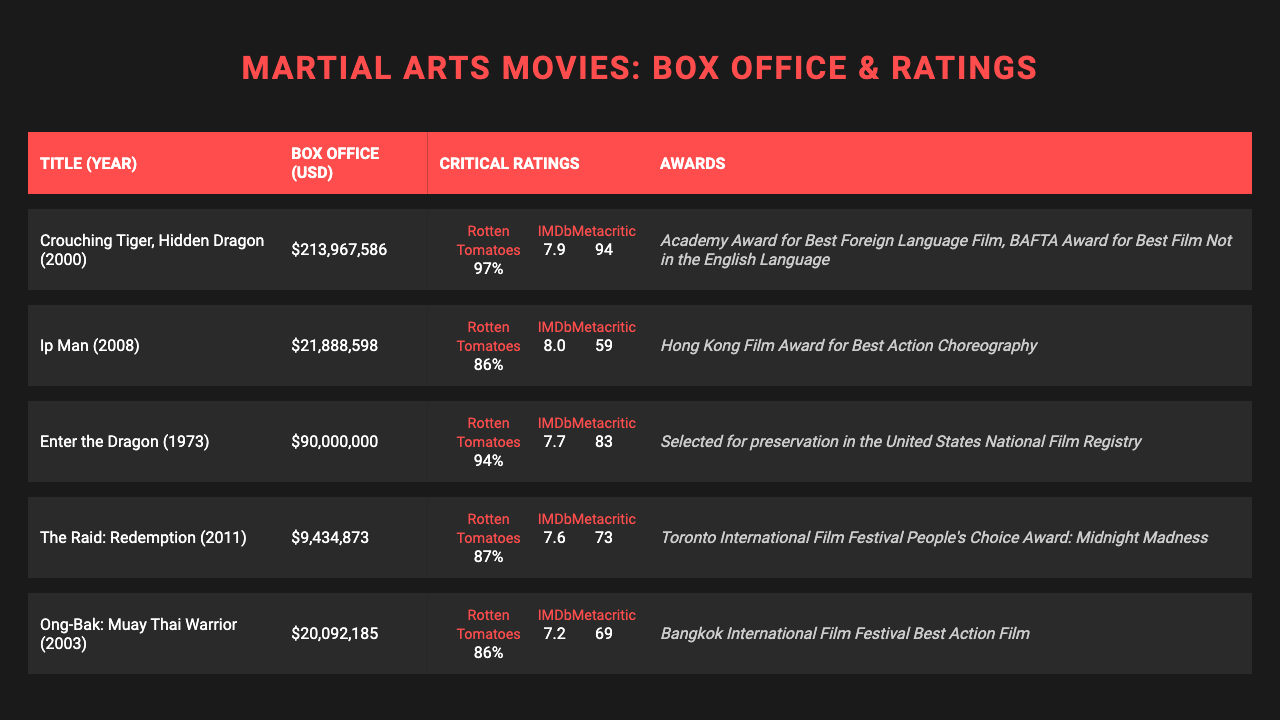What is the box office earning for "Crouching Tiger, Hidden Dragon"? The box office earning is listed directly in the table for each movie. For "Crouching Tiger, Hidden Dragon," it states the earning as $213,967,586.
Answer: $213,967,586 Which movie has the highest average critical rating? To find the highest average rating, we will calculate the average of the available ratings (Rotten Tomatoes, IMDb, and Metacritic) for each movie. The averages are: "Crouching Tiger, Hidden Dragon" (96.67), "Enter the Dragon" (90.33), "Ip Man" (78.33), "The Raid: Redemption" (79.33), and "Ong-Bak: Muay Thai Warrior" (74.33). "Crouching Tiger, Hidden Dragon" has the highest average rating.
Answer: Crouching Tiger, Hidden Dragon Did "The Raid: Redemption" win any awards? The table lists the awards for each movie under a specific column. "The Raid: Redemption" has one award listed: "Toronto International Film Festival People's Choice Award: Midnight Madness". Since it won this award, the answer is yes.
Answer: Yes What is the difference in box office earnings between "Ip Man" and "Ong-Bak: Muay Thai Warrior"? The box office earnings for "Ip Man" is $21,888,598, and for "Ong-Bak: Muay Thai Warrior," it's $20,092,185. The difference is calculated as $21,888,598 - $20,092,185 = $1,796,413.
Answer: $1,796,413 Which movie released in 2003 has the lowest IMDb rating? From the table, we can filter the movies released in 2003. The only movie is "Ong-Bak: Muay Thai Warrior," which has an IMDb rating of 7.2. Since it’s the only movie from that year, it has the lowest rating by default.
Answer: Ong-Bak: Muay Thai Warrior What percent of the box office earnings of "Enter the Dragon" (USD 90,000,000) does "Ong-Bak: Muay Thai Warrior" (USD 20,092,185) represent? The percentage can be calculated by dividing the box office of "Ong-Bak: Muay Thai Warrior" by that of "Enter the Dragon" and multiplying by 100: (20,092,185 / 90,000,000) * 100 ≈ 22.32%.
Answer: 22.32% How many awards does "Crouching Tiger, Hidden Dragon" have? We can directly count the awards listed under the column for "Crouching Tiger, Hidden Dragon." It shows two awards: "Academy Award for Best Foreign Language Film" and "BAFTA Award for Best Film Not in the English Language." Thus, there are two awards in total.
Answer: 2 Is it true that "Ip Man" has a higher Rotten Tomatoes rating than "The Raid: Redemption"? By checking the Rotten Tomatoes ratings from the table, "Ip Man" has a rating of 86%, while "The Raid: Redemption" has a rating of 87%. Since 86% is less than 87%, the statement is false.
Answer: No What is the total box office earnings for all the movies combined? We need to sum the box office earnings for all movies listed in the table: $213,967,586 + $21,888,598 + $90,000,000 + $9,434,873 + $20,092,185 = $355,383,242.
Answer: $355,383,242 Which movie received an Academy Award? The table indicates that "Crouching Tiger, Hidden Dragon" received the "Academy Award for Best Foreign Language Film" as one of its listed awards.
Answer: Crouching Tiger, Hidden Dragon 